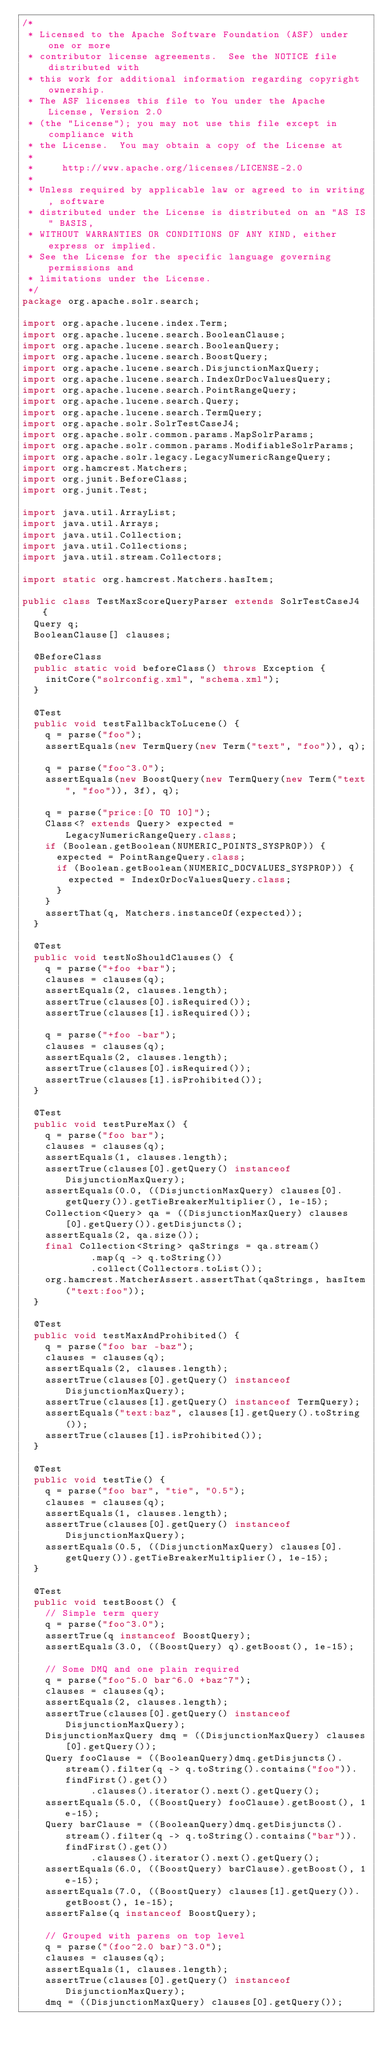Convert code to text. <code><loc_0><loc_0><loc_500><loc_500><_Java_>/*
 * Licensed to the Apache Software Foundation (ASF) under one or more
 * contributor license agreements.  See the NOTICE file distributed with
 * this work for additional information regarding copyright ownership.
 * The ASF licenses this file to You under the Apache License, Version 2.0
 * (the "License"); you may not use this file except in compliance with
 * the License.  You may obtain a copy of the License at
 *
 *     http://www.apache.org/licenses/LICENSE-2.0
 *
 * Unless required by applicable law or agreed to in writing, software
 * distributed under the License is distributed on an "AS IS" BASIS,
 * WITHOUT WARRANTIES OR CONDITIONS OF ANY KIND, either express or implied.
 * See the License for the specific language governing permissions and
 * limitations under the License.
 */
package org.apache.solr.search;

import org.apache.lucene.index.Term;
import org.apache.lucene.search.BooleanClause;
import org.apache.lucene.search.BooleanQuery;
import org.apache.lucene.search.BoostQuery;
import org.apache.lucene.search.DisjunctionMaxQuery;
import org.apache.lucene.search.IndexOrDocValuesQuery;
import org.apache.lucene.search.PointRangeQuery;
import org.apache.lucene.search.Query;
import org.apache.lucene.search.TermQuery;
import org.apache.solr.SolrTestCaseJ4;
import org.apache.solr.common.params.MapSolrParams;
import org.apache.solr.common.params.ModifiableSolrParams;
import org.apache.solr.legacy.LegacyNumericRangeQuery;
import org.hamcrest.Matchers;
import org.junit.BeforeClass;
import org.junit.Test;

import java.util.ArrayList;
import java.util.Arrays;
import java.util.Collection;
import java.util.Collections;
import java.util.stream.Collectors;

import static org.hamcrest.Matchers.hasItem;

public class TestMaxScoreQueryParser extends SolrTestCaseJ4 {
  Query q;
  BooleanClause[] clauses;

  @BeforeClass
  public static void beforeClass() throws Exception {
    initCore("solrconfig.xml", "schema.xml");
  }

  @Test
  public void testFallbackToLucene() {
    q = parse("foo");
    assertEquals(new TermQuery(new Term("text", "foo")), q);

    q = parse("foo^3.0");
    assertEquals(new BoostQuery(new TermQuery(new Term("text", "foo")), 3f), q);

    q = parse("price:[0 TO 10]");
    Class<? extends Query> expected = LegacyNumericRangeQuery.class;
    if (Boolean.getBoolean(NUMERIC_POINTS_SYSPROP)) {
      expected = PointRangeQuery.class;
      if (Boolean.getBoolean(NUMERIC_DOCVALUES_SYSPROP)) {
        expected = IndexOrDocValuesQuery.class;
      }
    }
    assertThat(q, Matchers.instanceOf(expected));
  }

  @Test
  public void testNoShouldClauses() {
    q = parse("+foo +bar");
    clauses = clauses(q);
    assertEquals(2, clauses.length);
    assertTrue(clauses[0].isRequired());
    assertTrue(clauses[1].isRequired());

    q = parse("+foo -bar");
    clauses = clauses(q);
    assertEquals(2, clauses.length);
    assertTrue(clauses[0].isRequired());
    assertTrue(clauses[1].isProhibited());
  }

  @Test
  public void testPureMax() {
    q = parse("foo bar");
    clauses = clauses(q);
    assertEquals(1, clauses.length);
    assertTrue(clauses[0].getQuery() instanceof DisjunctionMaxQuery);
    assertEquals(0.0, ((DisjunctionMaxQuery) clauses[0].getQuery()).getTieBreakerMultiplier(), 1e-15);
    Collection<Query> qa = ((DisjunctionMaxQuery) clauses[0].getQuery()).getDisjuncts();
    assertEquals(2, qa.size());
    final Collection<String> qaStrings = qa.stream()
            .map(q -> q.toString())
            .collect(Collectors.toList());
    org.hamcrest.MatcherAssert.assertThat(qaStrings, hasItem("text:foo"));
  }

  @Test
  public void testMaxAndProhibited() {
    q = parse("foo bar -baz");
    clauses = clauses(q);
    assertEquals(2, clauses.length);
    assertTrue(clauses[0].getQuery() instanceof DisjunctionMaxQuery);
    assertTrue(clauses[1].getQuery() instanceof TermQuery);
    assertEquals("text:baz", clauses[1].getQuery().toString());
    assertTrue(clauses[1].isProhibited());
  }

  @Test
  public void testTie() {
    q = parse("foo bar", "tie", "0.5");
    clauses = clauses(q);
    assertEquals(1, clauses.length);
    assertTrue(clauses[0].getQuery() instanceof DisjunctionMaxQuery);
    assertEquals(0.5, ((DisjunctionMaxQuery) clauses[0].getQuery()).getTieBreakerMultiplier(), 1e-15);
  }

  @Test
  public void testBoost() {
    // Simple term query
    q = parse("foo^3.0");
    assertTrue(q instanceof BoostQuery);
    assertEquals(3.0, ((BoostQuery) q).getBoost(), 1e-15);

    // Some DMQ and one plain required
    q = parse("foo^5.0 bar^6.0 +baz^7");
    clauses = clauses(q);
    assertEquals(2, clauses.length);
    assertTrue(clauses[0].getQuery() instanceof DisjunctionMaxQuery);
    DisjunctionMaxQuery dmq = ((DisjunctionMaxQuery) clauses[0].getQuery());
    Query fooClause = ((BooleanQuery)dmq.getDisjuncts().stream().filter(q -> q.toString().contains("foo")).findFirst().get())
            .clauses().iterator().next().getQuery();
    assertEquals(5.0, ((BoostQuery) fooClause).getBoost(), 1e-15);
    Query barClause = ((BooleanQuery)dmq.getDisjuncts().stream().filter(q -> q.toString().contains("bar")).findFirst().get())
            .clauses().iterator().next().getQuery();
    assertEquals(6.0, ((BoostQuery) barClause).getBoost(), 1e-15);
    assertEquals(7.0, ((BoostQuery) clauses[1].getQuery()).getBoost(), 1e-15);
    assertFalse(q instanceof BoostQuery);

    // Grouped with parens on top level
    q = parse("(foo^2.0 bar)^3.0");
    clauses = clauses(q);
    assertEquals(1, clauses.length);
    assertTrue(clauses[0].getQuery() instanceof DisjunctionMaxQuery);
    dmq = ((DisjunctionMaxQuery) clauses[0].getQuery());</code> 